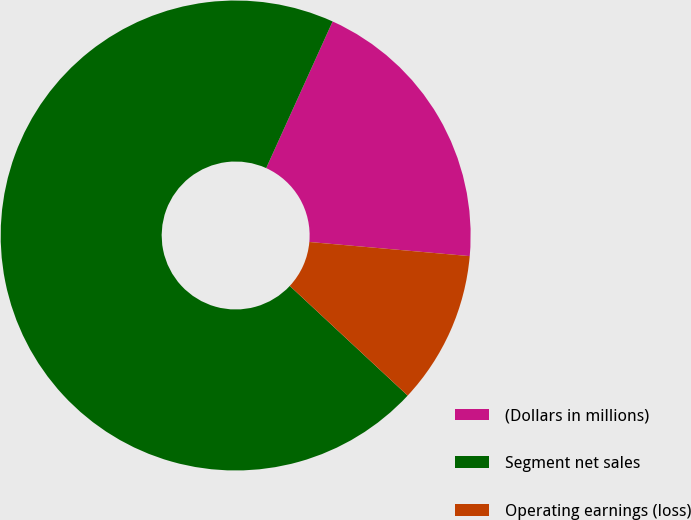Convert chart. <chart><loc_0><loc_0><loc_500><loc_500><pie_chart><fcel>(Dollars in millions)<fcel>Segment net sales<fcel>Operating earnings (loss)<nl><fcel>19.63%<fcel>69.84%<fcel>10.53%<nl></chart> 